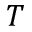<formula> <loc_0><loc_0><loc_500><loc_500>T</formula> 